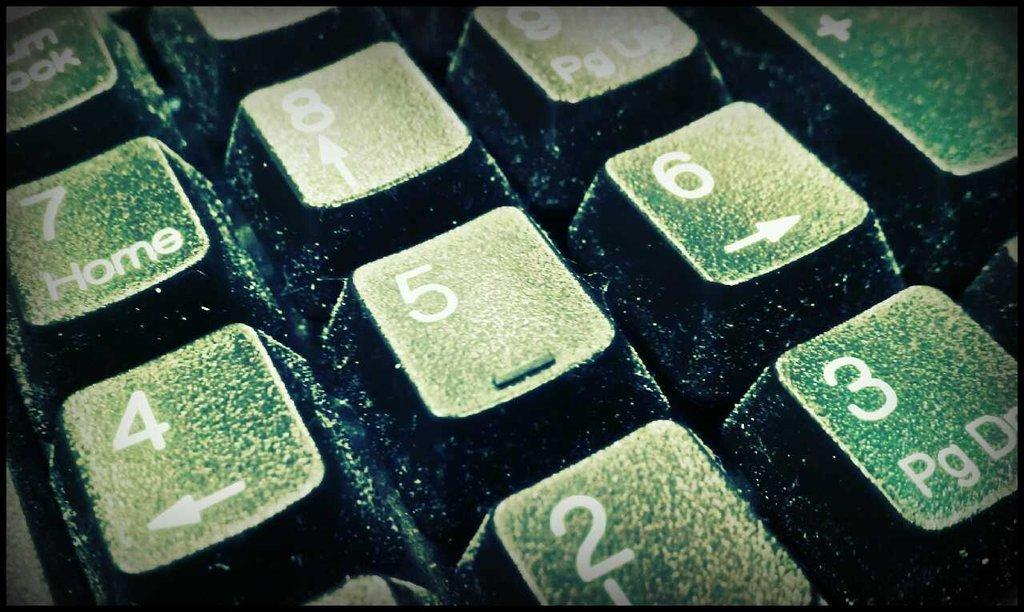<image>
Create a compact narrative representing the image presented. A closeup of a keyboard shows the number keys. 